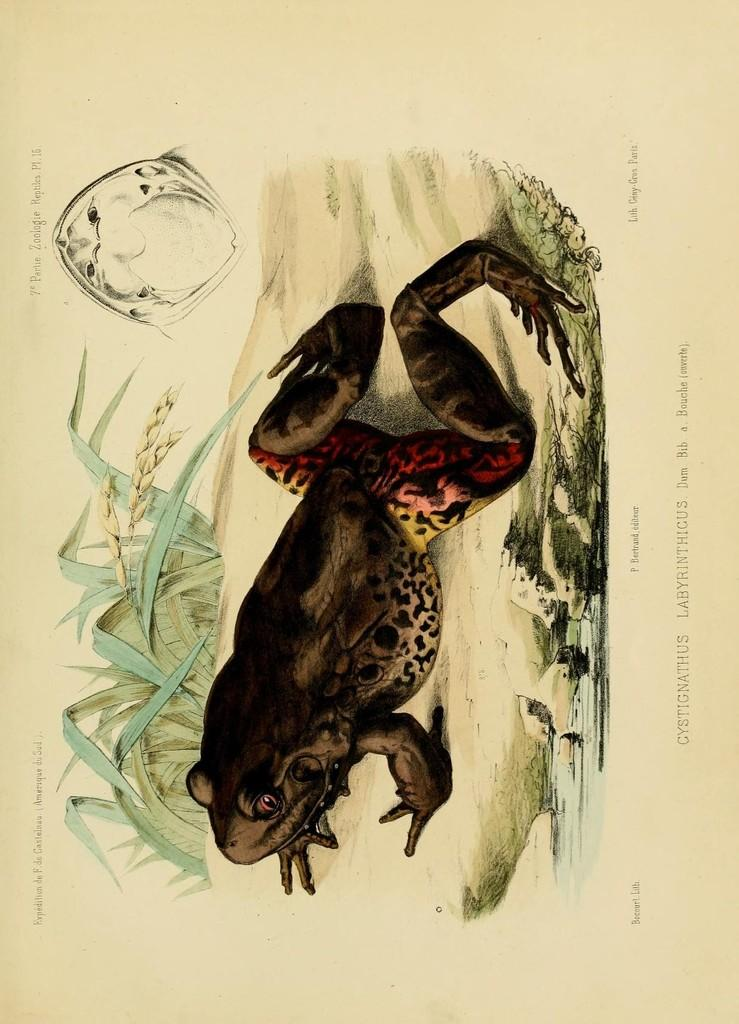What is the main subject of the image? The main subject of the image is an art of a frog. Can you describe the color of the frog? The frog is in brown color. What is the color of the paper on which the art is drawn? The paper is in cream color. What route does the frog take to reach its mom in the image? There is no route or mom present in the image; it only features an art of a frog on a cream-colored paper. 